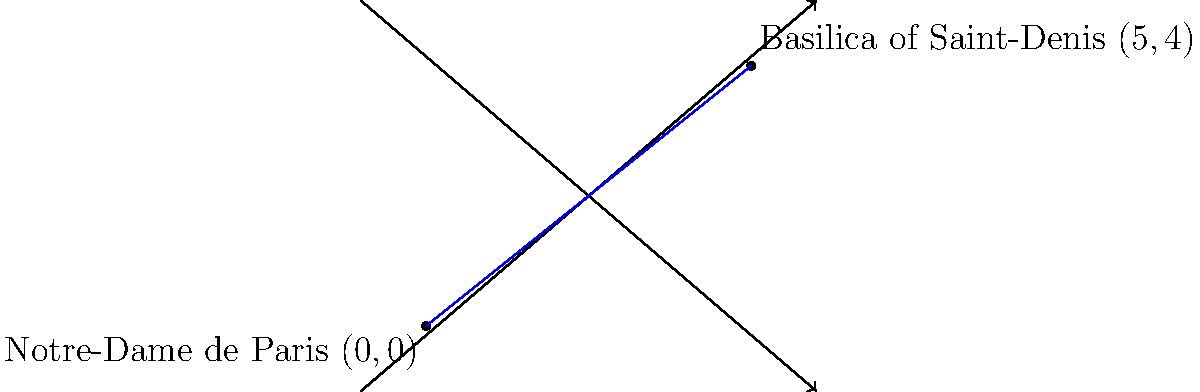As a French historian studying religious sites, you are interested in calculating the distance between two significant medieval churches in Paris. Notre-Dame de Paris is located at coordinates $(0,0)$ and the Basilica of Saint-Denis is at $(5,4)$ on a coordinate plane where each unit represents 1 kilometer. Using the distance formula, calculate the straight-line distance between these two historical religious sites. To solve this problem, we'll use the distance formula derived from the Pythagorean theorem:

1) The distance formula is: $d = \sqrt{(x_2-x_1)^2 + (y_2-y_1)^2}$

2) We have:
   Notre-Dame de Paris: $(x_1, y_1) = (0, 0)$
   Basilica of Saint-Denis: $(x_2, y_2) = (5, 4)$

3) Let's substitute these values into the formula:
   $d = \sqrt{(5-0)^2 + (4-0)^2}$

4) Simplify:
   $d = \sqrt{5^2 + 4^2}$

5) Calculate the squares:
   $d = \sqrt{25 + 16}$

6) Add under the square root:
   $d = \sqrt{41}$

7) The square root of 41 is approximately 6.40 km.

This distance represents the straight-line distance between these two historically significant religious sites, providing insight into their spatial relationship in medieval Paris.
Answer: $\sqrt{41}$ km or approximately 6.40 km 